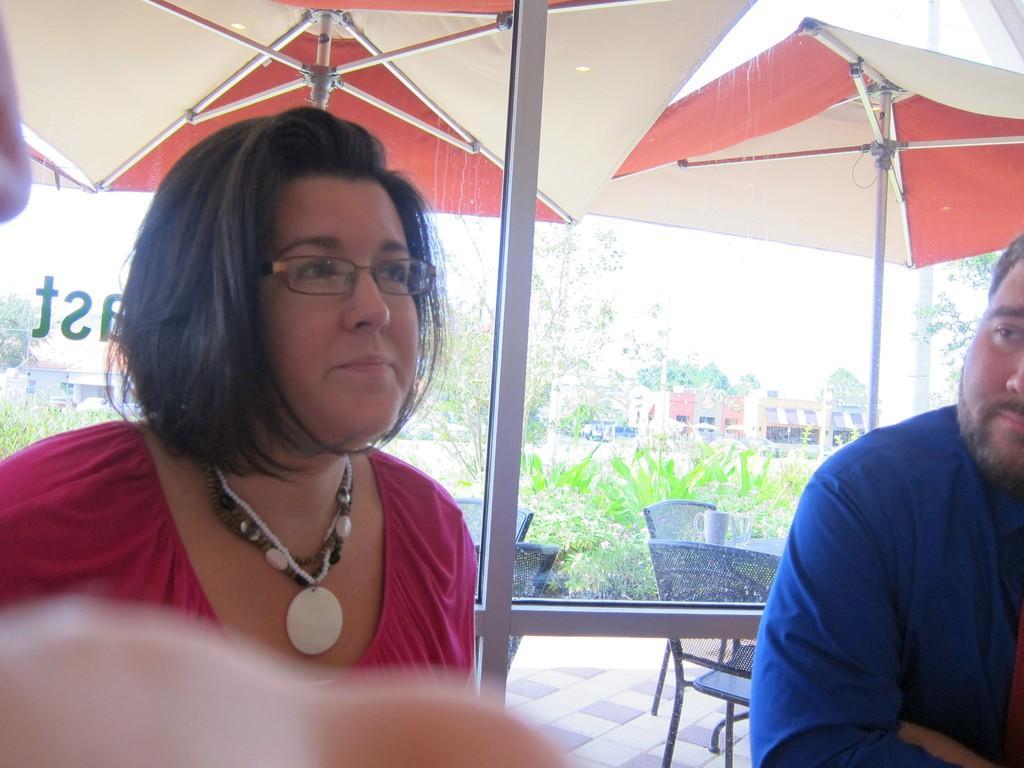Describe this image in one or two sentences. In this image I can see a woman wearing red colored dress and a man wearing blue colored dress. In the background I can see few trees, few buildings, few chairs, few umbrellas, a cup and the sky. 